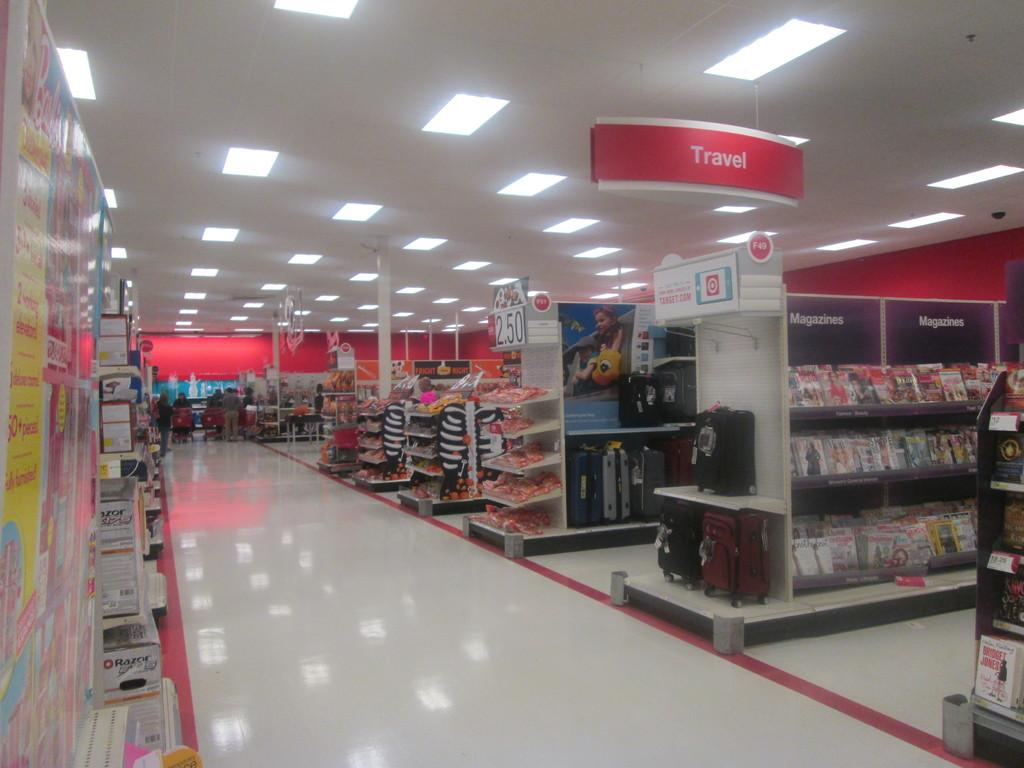<image>
Render a clear and concise summary of the photo. Travel section inside of a department store with some candy on an end isle for $2.50. 